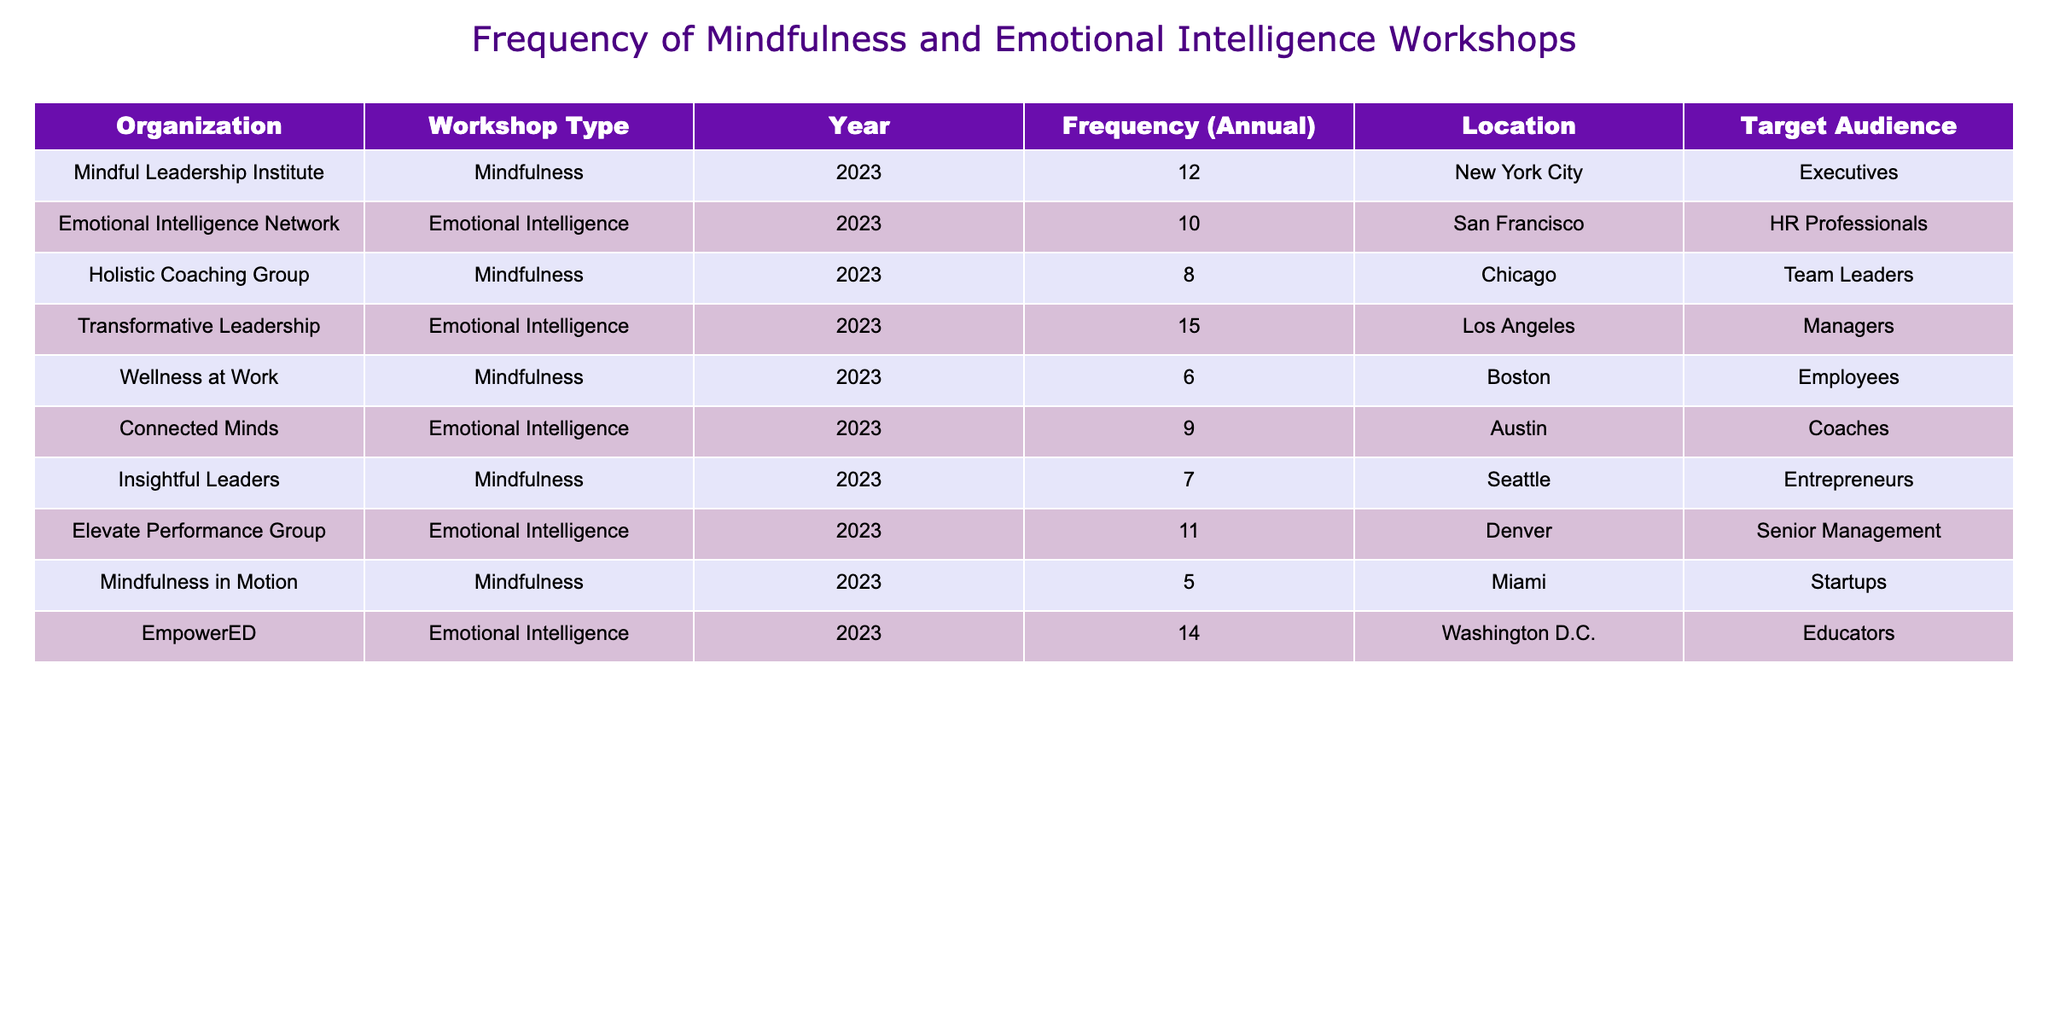What is the highest frequency of workshops offered by an organization? The organization with the highest frequency of workshops is "Transformative Leadership," which offers 15 workshops annually.
Answer: 15 Which organization targets team leaders with mindfulness workshops? The organization targeting team leaders with mindfulness workshops is "Holistic Coaching Group," which offers 8 workshops annually.
Answer: Holistic Coaching Group How many workshops does the Emotional Intelligence Network offer? The Emotional Intelligence Network offers 10 workshops annually, as shown in the table under the corresponding section.
Answer: 10 What's the total number of mindfulness workshops offered across all organizations? To get the total, I will sum the frequencies for mindfulness workshops: 12 + 8 + 6 + 7 + 5 = 38. Therefore, the total number of mindfulness workshops is 38.
Answer: 38 Is there any organization in Miami that offers mindfulness workshops? Yes, "Mindfulness in Motion" is located in Miami and offers mindfulness workshops.
Answer: Yes What is the average frequency of emotional intelligence workshops offered by organizations? The frequencies for emotional intelligence workshops are 10, 15, 9, 11, and 14. To find the average, I sum them: 10 + 15 + 9 + 11 + 14 = 59, then divide by 5 (the number of organizations): 59/5 = 11.8, which rounds to 12.
Answer: 12 Which location has the fewest workshops for mindfulness? The location with the fewest workshops for mindfulness is Miami with 5 workshops offered by "Mindfulness in Motion."
Answer: Miami How many organizations offer emotional intelligence workshops at a frequency of 10 or more? The organizations offering emotional intelligence workshops at a frequency of 10 or more are Emotional Intelligence Network (10), Transformative Leadership (15), Elevate Performance Group (11), and EmpowerED (14). That makes a total of 4 organizations.
Answer: 4 